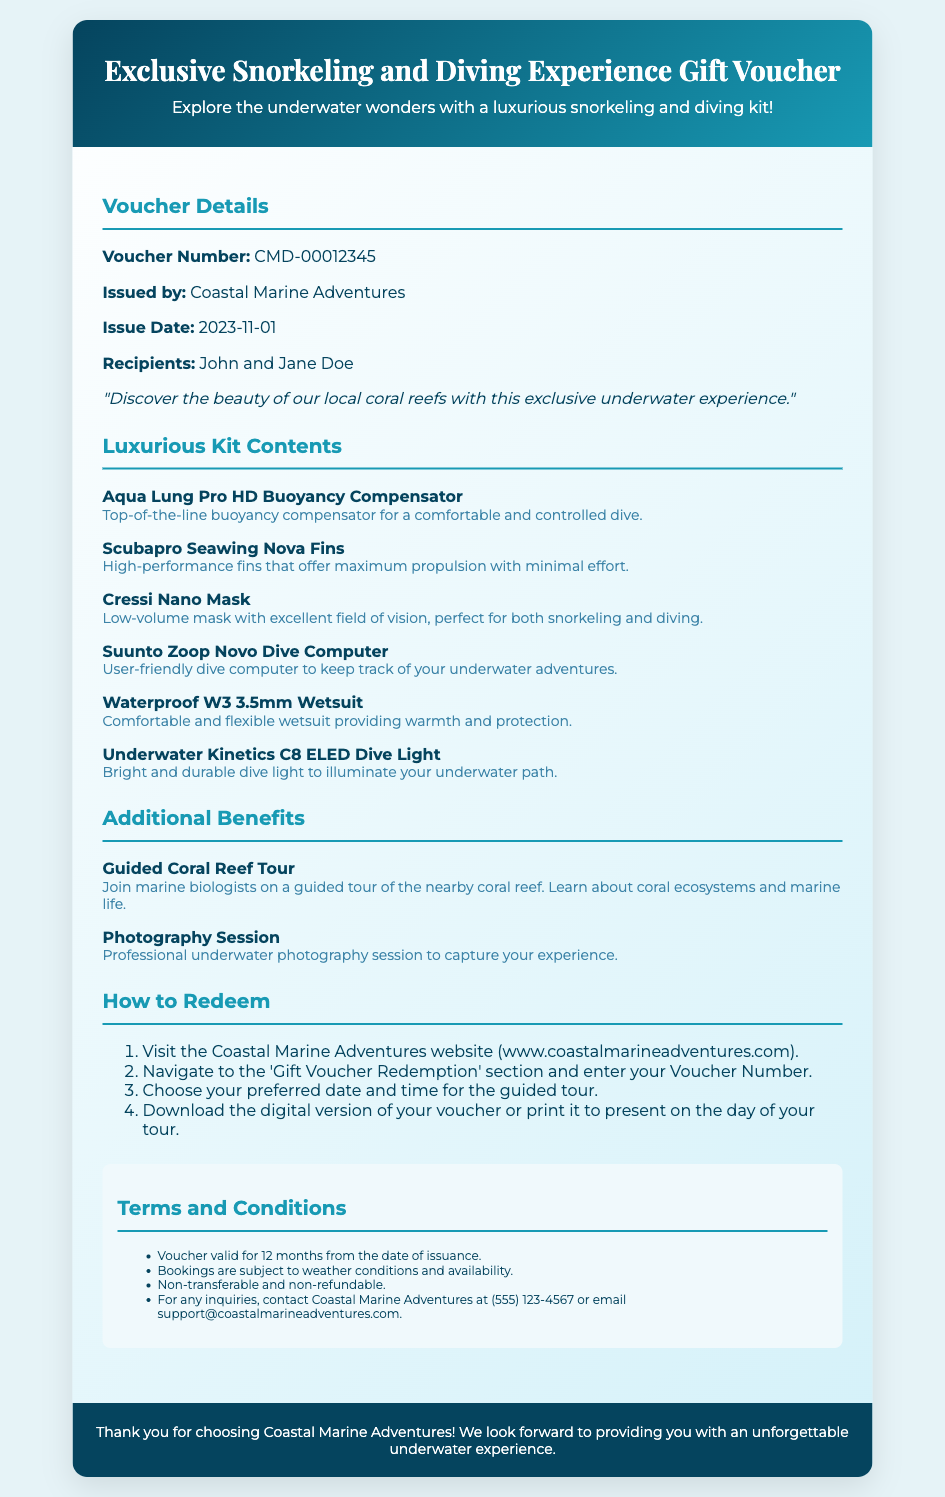What is the voucher number? The voucher number is provided in the document under 'Voucher Details'.
Answer: CMD-00012345 Who issued the voucher? The issuer is mentioned in the 'Voucher Details' section.
Answer: Coastal Marine Adventures When was the voucher issued? The issuance date of the voucher is listed in the 'Voucher Details' section.
Answer: 2023-11-01 What is included in the snorkeling and diving kit? This question covers the contents listed in the 'Luxurious Kit Contents' section.
Answer: Aqua Lung Pro HD Buoyancy Compensator, Scubapro Seawing Nova Fins, Cressi Nano Mask, Suunto Zoop Novo Dive Computer, Waterproof W3 3.5mm Wetsuit, Underwater Kinetics C8 ELED Dive Light What additional benefit is provided with the voucher? The document contains a section on additional benefits that come with the voucher.
Answer: Guided Coral Reef Tour How can the voucher be redeemed? This refers to the 'How to Redeem' section that provides steps for redemption.
Answer: Visit the Coastal Marine Adventures website What are the terms for the voucher's validity? The terms include information about the validity period, as noted in the 'Terms and Conditions' section.
Answer: 12 months What should those interested in inquiries contact? This seeks information on how to get support or inquiries related to the voucher.
Answer: (555) 123-4567 Is the voucher transferable? This question addresses a term mentioned in the document regarding the voucher's conditions.
Answer: Non-transferable 